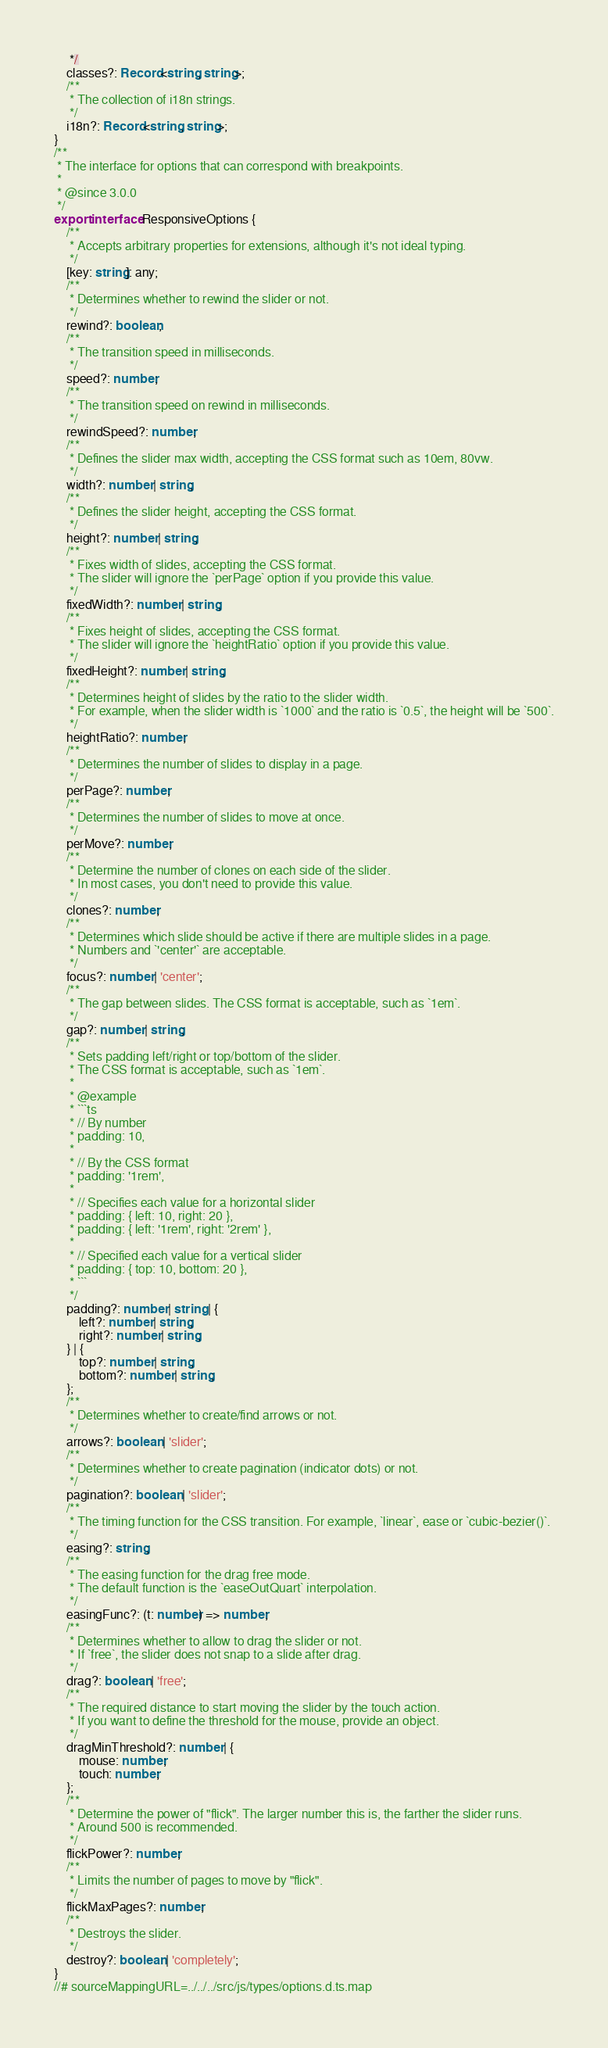Convert code to text. <code><loc_0><loc_0><loc_500><loc_500><_TypeScript_>     */
    classes?: Record<string, string>;
    /**
     * The collection of i18n strings.
     */
    i18n?: Record<string, string>;
}
/**
 * The interface for options that can correspond with breakpoints.
 *
 * @since 3.0.0
 */
export interface ResponsiveOptions {
    /**
     * Accepts arbitrary properties for extensions, although it's not ideal typing.
     */
    [key: string]: any;
    /**
     * Determines whether to rewind the slider or not.
     */
    rewind?: boolean;
    /**
     * The transition speed in milliseconds.
     */
    speed?: number;
    /**
     * The transition speed on rewind in milliseconds.
     */
    rewindSpeed?: number;
    /**
     * Defines the slider max width, accepting the CSS format such as 10em, 80vw.
     */
    width?: number | string;
    /**
     * Defines the slider height, accepting the CSS format.
     */
    height?: number | string;
    /**
     * Fixes width of slides, accepting the CSS format.
     * The slider will ignore the `perPage` option if you provide this value.
     */
    fixedWidth?: number | string;
    /**
     * Fixes height of slides, accepting the CSS format.
     * The slider will ignore the `heightRatio` option if you provide this value.
     */
    fixedHeight?: number | string;
    /**
     * Determines height of slides by the ratio to the slider width.
     * For example, when the slider width is `1000` and the ratio is `0.5`, the height will be `500`.
     */
    heightRatio?: number;
    /**
     * Determines the number of slides to display in a page.
     */
    perPage?: number;
    /**
     * Determines the number of slides to move at once.
     */
    perMove?: number;
    /**
     * Determine the number of clones on each side of the slider.
     * In most cases, you don't need to provide this value.
     */
    clones?: number;
    /**
     * Determines which slide should be active if there are multiple slides in a page.
     * Numbers and `'center'` are acceptable.
     */
    focus?: number | 'center';
    /**
     * The gap between slides. The CSS format is acceptable, such as `1em`.
     */
    gap?: number | string;
    /**
     * Sets padding left/right or top/bottom of the slider.
     * The CSS format is acceptable, such as `1em`.
     *
     * @example
     * ```ts
     * // By number
     * padding: 10,
     *
     * // By the CSS format
     * padding: '1rem',
     *
     * // Specifies each value for a horizontal slider
     * padding: { left: 10, right: 20 },
     * padding: { left: '1rem', right: '2rem' },
     *
     * // Specified each value for a vertical slider
     * padding: { top: 10, bottom: 20 },
     * ```
     */
    padding?: number | string | {
        left?: number | string;
        right?: number | string;
    } | {
        top?: number | string;
        bottom?: number | string;
    };
    /**
     * Determines whether to create/find arrows or not.
     */
    arrows?: boolean | 'slider';
    /**
     * Determines whether to create pagination (indicator dots) or not.
     */
    pagination?: boolean | 'slider';
    /**
     * The timing function for the CSS transition. For example, `linear`, ease or `cubic-bezier()`.
     */
    easing?: string;
    /**
     * The easing function for the drag free mode.
     * The default function is the `easeOutQuart` interpolation.
     */
    easingFunc?: (t: number) => number;
    /**
     * Determines whether to allow to drag the slider or not.
     * If `free`, the slider does not snap to a slide after drag.
     */
    drag?: boolean | 'free';
    /**
     * The required distance to start moving the slider by the touch action.
     * If you want to define the threshold for the mouse, provide an object.
     */
    dragMinThreshold?: number | {
        mouse: number;
        touch: number;
    };
    /**
     * Determine the power of "flick". The larger number this is, the farther the slider runs.
     * Around 500 is recommended.
     */
    flickPower?: number;
    /**
     * Limits the number of pages to move by "flick".
     */
    flickMaxPages?: number;
    /**
     * Destroys the slider.
     */
    destroy?: boolean | 'completely';
}
//# sourceMappingURL=../../../src/js/types/options.d.ts.map</code> 